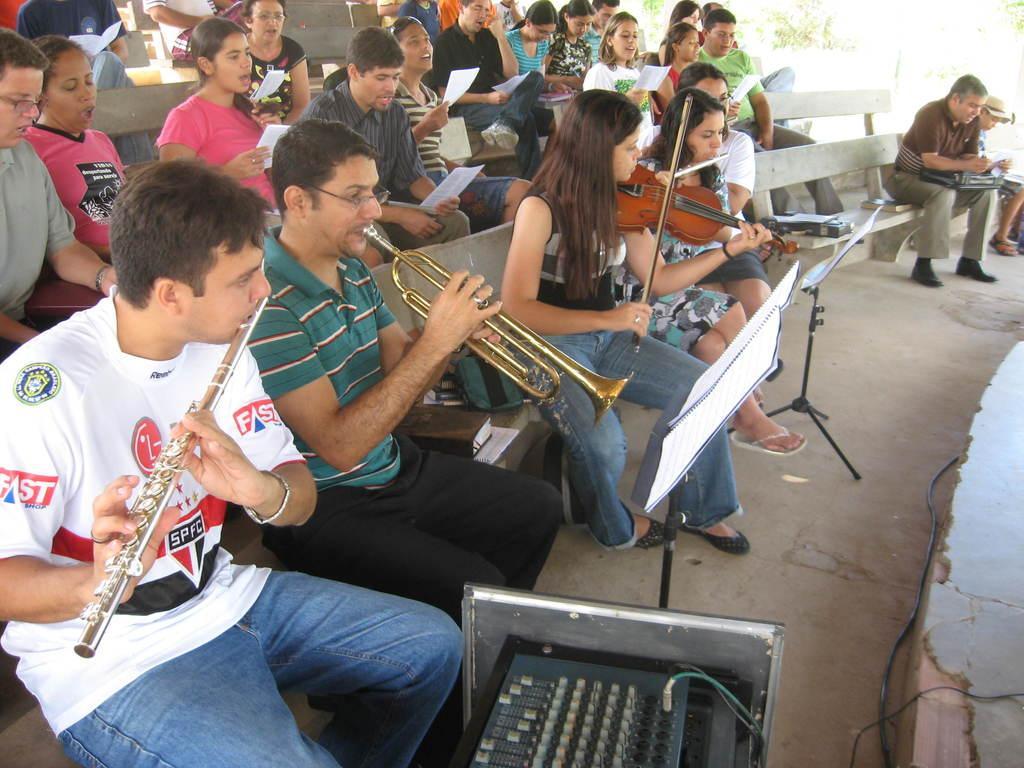Can you describe this image briefly? In this image we can see people sitting on benches. Some people are playing musical instruments. Some are holding papers. Also there are music note stands with books. Also there is another device. And there are wires. 